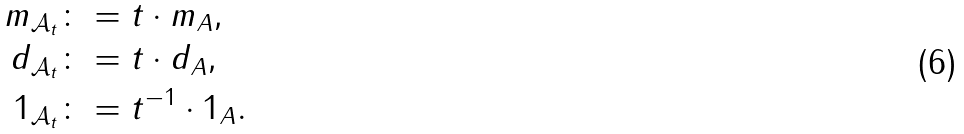<formula> <loc_0><loc_0><loc_500><loc_500>m _ { \mathcal { A } _ { t } } & \colon = t \cdot m _ { A } , \\ d _ { \mathcal { A } _ { t } } & \colon = t \cdot d _ { A } , \\ 1 _ { \mathcal { A } _ { t } } & \colon = t ^ { - 1 } \cdot 1 _ { A } .</formula> 